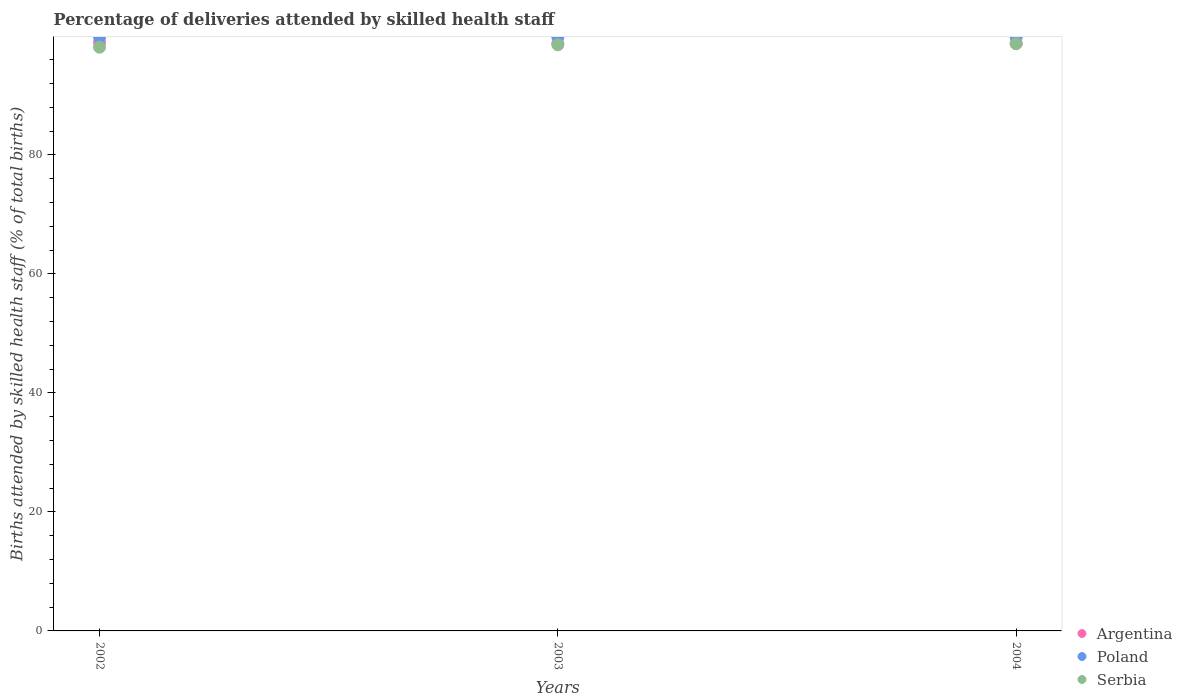How many different coloured dotlines are there?
Offer a very short reply. 3. Is the number of dotlines equal to the number of legend labels?
Your response must be concise. Yes. What is the percentage of births attended by skilled health staff in Serbia in 2003?
Give a very brief answer. 98.5. Across all years, what is the maximum percentage of births attended by skilled health staff in Poland?
Keep it short and to the point. 99.8. Across all years, what is the minimum percentage of births attended by skilled health staff in Poland?
Offer a very short reply. 99.8. What is the total percentage of births attended by skilled health staff in Poland in the graph?
Your answer should be compact. 299.4. What is the difference between the percentage of births attended by skilled health staff in Poland in 2002 and that in 2004?
Offer a very short reply. 0. What is the difference between the percentage of births attended by skilled health staff in Poland in 2004 and the percentage of births attended by skilled health staff in Argentina in 2003?
Ensure brevity in your answer.  1.1. What is the average percentage of births attended by skilled health staff in Argentina per year?
Your answer should be very brief. 98.77. In the year 2003, what is the difference between the percentage of births attended by skilled health staff in Argentina and percentage of births attended by skilled health staff in Serbia?
Ensure brevity in your answer.  0.2. In how many years, is the percentage of births attended by skilled health staff in Argentina greater than 40 %?
Your answer should be compact. 3. What is the ratio of the percentage of births attended by skilled health staff in Serbia in 2002 to that in 2003?
Offer a terse response. 1. What is the difference between the highest and the second highest percentage of births attended by skilled health staff in Serbia?
Make the answer very short. 0.2. What is the difference between the highest and the lowest percentage of births attended by skilled health staff in Poland?
Your answer should be compact. 0. In how many years, is the percentage of births attended by skilled health staff in Argentina greater than the average percentage of births attended by skilled health staff in Argentina taken over all years?
Offer a very short reply. 1. Is the sum of the percentage of births attended by skilled health staff in Argentina in 2002 and 2003 greater than the maximum percentage of births attended by skilled health staff in Serbia across all years?
Your response must be concise. Yes. Is it the case that in every year, the sum of the percentage of births attended by skilled health staff in Poland and percentage of births attended by skilled health staff in Serbia  is greater than the percentage of births attended by skilled health staff in Argentina?
Offer a terse response. Yes. Is the percentage of births attended by skilled health staff in Argentina strictly greater than the percentage of births attended by skilled health staff in Serbia over the years?
Keep it short and to the point. No. Is the percentage of births attended by skilled health staff in Poland strictly less than the percentage of births attended by skilled health staff in Serbia over the years?
Your answer should be compact. No. How many dotlines are there?
Your response must be concise. 3. Are the values on the major ticks of Y-axis written in scientific E-notation?
Provide a succinct answer. No. Does the graph contain any zero values?
Your response must be concise. No. Does the graph contain grids?
Offer a terse response. No. Where does the legend appear in the graph?
Give a very brief answer. Bottom right. How are the legend labels stacked?
Your response must be concise. Vertical. What is the title of the graph?
Offer a terse response. Percentage of deliveries attended by skilled health staff. Does "Bermuda" appear as one of the legend labels in the graph?
Provide a succinct answer. No. What is the label or title of the X-axis?
Give a very brief answer. Years. What is the label or title of the Y-axis?
Offer a very short reply. Births attended by skilled health staff (% of total births). What is the Births attended by skilled health staff (% of total births) of Argentina in 2002?
Your response must be concise. 98.9. What is the Births attended by skilled health staff (% of total births) in Poland in 2002?
Your answer should be compact. 99.8. What is the Births attended by skilled health staff (% of total births) of Serbia in 2002?
Your response must be concise. 98.1. What is the Births attended by skilled health staff (% of total births) in Argentina in 2003?
Your answer should be compact. 98.7. What is the Births attended by skilled health staff (% of total births) in Poland in 2003?
Offer a very short reply. 99.8. What is the Births attended by skilled health staff (% of total births) of Serbia in 2003?
Your answer should be very brief. 98.5. What is the Births attended by skilled health staff (% of total births) in Argentina in 2004?
Make the answer very short. 98.7. What is the Births attended by skilled health staff (% of total births) of Poland in 2004?
Your response must be concise. 99.8. What is the Births attended by skilled health staff (% of total births) of Serbia in 2004?
Offer a terse response. 98.7. Across all years, what is the maximum Births attended by skilled health staff (% of total births) in Argentina?
Your answer should be compact. 98.9. Across all years, what is the maximum Births attended by skilled health staff (% of total births) in Poland?
Give a very brief answer. 99.8. Across all years, what is the maximum Births attended by skilled health staff (% of total births) in Serbia?
Offer a terse response. 98.7. Across all years, what is the minimum Births attended by skilled health staff (% of total births) of Argentina?
Your response must be concise. 98.7. Across all years, what is the minimum Births attended by skilled health staff (% of total births) of Poland?
Provide a succinct answer. 99.8. Across all years, what is the minimum Births attended by skilled health staff (% of total births) in Serbia?
Give a very brief answer. 98.1. What is the total Births attended by skilled health staff (% of total births) in Argentina in the graph?
Provide a short and direct response. 296.3. What is the total Births attended by skilled health staff (% of total births) in Poland in the graph?
Provide a short and direct response. 299.4. What is the total Births attended by skilled health staff (% of total births) of Serbia in the graph?
Give a very brief answer. 295.3. What is the difference between the Births attended by skilled health staff (% of total births) of Argentina in 2002 and that in 2003?
Provide a succinct answer. 0.2. What is the difference between the Births attended by skilled health staff (% of total births) of Serbia in 2002 and that in 2003?
Provide a succinct answer. -0.4. What is the difference between the Births attended by skilled health staff (% of total births) of Poland in 2002 and that in 2004?
Ensure brevity in your answer.  0. What is the difference between the Births attended by skilled health staff (% of total births) in Argentina in 2003 and that in 2004?
Your answer should be compact. 0. What is the difference between the Births attended by skilled health staff (% of total births) in Argentina in 2002 and the Births attended by skilled health staff (% of total births) in Poland in 2003?
Your response must be concise. -0.9. What is the difference between the Births attended by skilled health staff (% of total births) in Argentina in 2002 and the Births attended by skilled health staff (% of total births) in Serbia in 2003?
Your answer should be very brief. 0.4. What is the difference between the Births attended by skilled health staff (% of total births) of Poland in 2002 and the Births attended by skilled health staff (% of total births) of Serbia in 2003?
Your answer should be compact. 1.3. What is the difference between the Births attended by skilled health staff (% of total births) of Argentina in 2002 and the Births attended by skilled health staff (% of total births) of Serbia in 2004?
Offer a very short reply. 0.2. What is the difference between the Births attended by skilled health staff (% of total births) of Poland in 2002 and the Births attended by skilled health staff (% of total births) of Serbia in 2004?
Keep it short and to the point. 1.1. What is the difference between the Births attended by skilled health staff (% of total births) in Argentina in 2003 and the Births attended by skilled health staff (% of total births) in Serbia in 2004?
Ensure brevity in your answer.  0. What is the average Births attended by skilled health staff (% of total births) in Argentina per year?
Provide a short and direct response. 98.77. What is the average Births attended by skilled health staff (% of total births) in Poland per year?
Your answer should be compact. 99.8. What is the average Births attended by skilled health staff (% of total births) of Serbia per year?
Give a very brief answer. 98.43. In the year 2002, what is the difference between the Births attended by skilled health staff (% of total births) in Argentina and Births attended by skilled health staff (% of total births) in Serbia?
Provide a short and direct response. 0.8. In the year 2002, what is the difference between the Births attended by skilled health staff (% of total births) in Poland and Births attended by skilled health staff (% of total births) in Serbia?
Your response must be concise. 1.7. In the year 2003, what is the difference between the Births attended by skilled health staff (% of total births) of Poland and Births attended by skilled health staff (% of total births) of Serbia?
Your response must be concise. 1.3. In the year 2004, what is the difference between the Births attended by skilled health staff (% of total births) in Argentina and Births attended by skilled health staff (% of total births) in Poland?
Your response must be concise. -1.1. In the year 2004, what is the difference between the Births attended by skilled health staff (% of total births) in Argentina and Births attended by skilled health staff (% of total births) in Serbia?
Your answer should be very brief. 0. What is the ratio of the Births attended by skilled health staff (% of total births) in Poland in 2002 to that in 2004?
Your answer should be compact. 1. What is the ratio of the Births attended by skilled health staff (% of total births) in Argentina in 2003 to that in 2004?
Your answer should be compact. 1. What is the ratio of the Births attended by skilled health staff (% of total births) of Poland in 2003 to that in 2004?
Make the answer very short. 1. What is the ratio of the Births attended by skilled health staff (% of total births) in Serbia in 2003 to that in 2004?
Provide a succinct answer. 1. What is the difference between the highest and the second highest Births attended by skilled health staff (% of total births) in Poland?
Your response must be concise. 0. What is the difference between the highest and the lowest Births attended by skilled health staff (% of total births) of Poland?
Make the answer very short. 0. What is the difference between the highest and the lowest Births attended by skilled health staff (% of total births) in Serbia?
Make the answer very short. 0.6. 